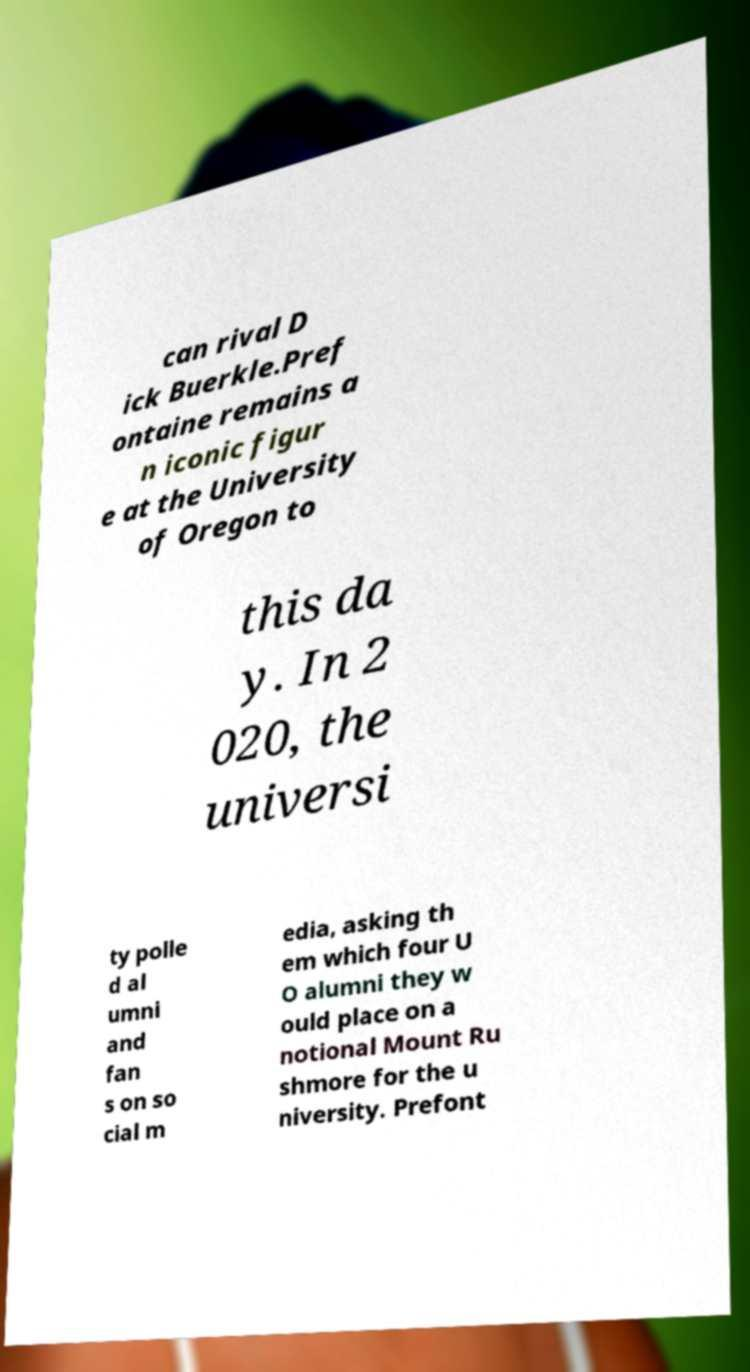Could you assist in decoding the text presented in this image and type it out clearly? can rival D ick Buerkle.Pref ontaine remains a n iconic figur e at the University of Oregon to this da y. In 2 020, the universi ty polle d al umni and fan s on so cial m edia, asking th em which four U O alumni they w ould place on a notional Mount Ru shmore for the u niversity. Prefont 